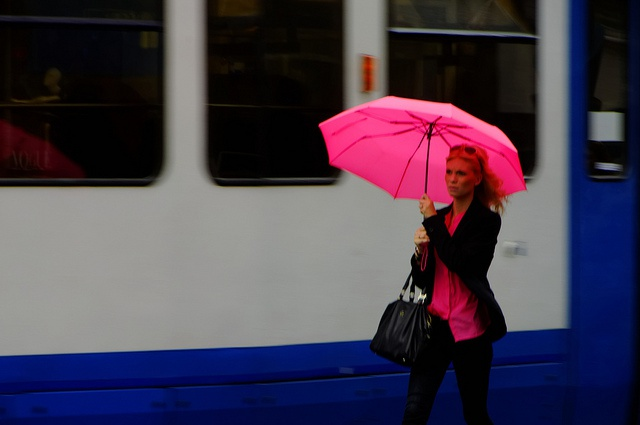Describe the objects in this image and their specific colors. I can see train in black, darkgray, navy, and gray tones, people in black, brown, and maroon tones, umbrella in black, brown, violet, magenta, and lightpink tones, and handbag in black, darkgray, navy, and gray tones in this image. 